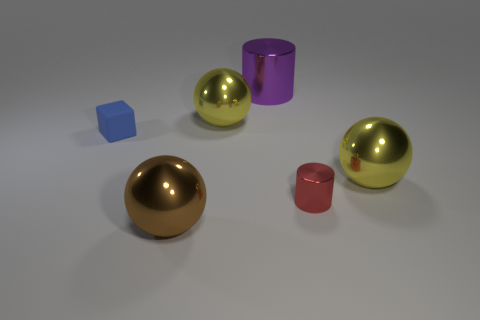Looking at the lighting and shadows, what can you infer about the light source in this scene? The shadows cast by the objects suggest that there is a single light source above and slightly to the right of the center of the image. The light source appears to be somewhat soft, given the diffuse nature of the shadows. 